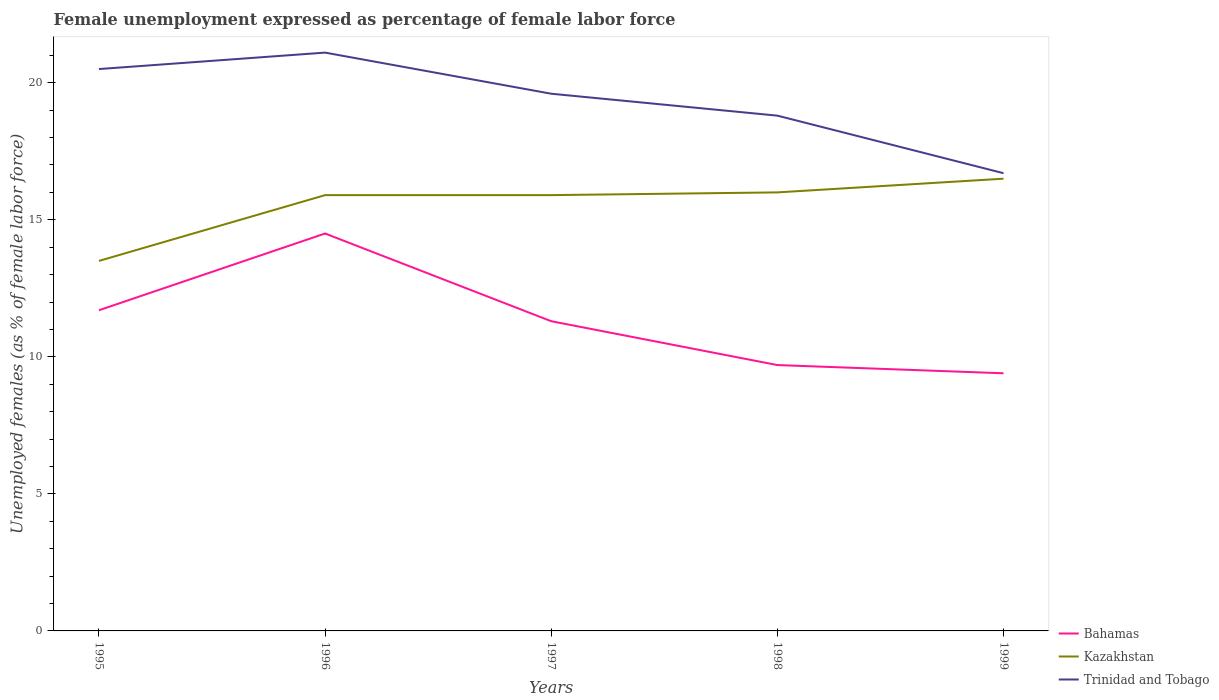How many different coloured lines are there?
Offer a terse response. 3. Is the number of lines equal to the number of legend labels?
Your answer should be compact. Yes. Across all years, what is the maximum unemployment in females in in Trinidad and Tobago?
Your response must be concise. 16.7. In which year was the unemployment in females in in Kazakhstan maximum?
Your answer should be very brief. 1995. What is the total unemployment in females in in Trinidad and Tobago in the graph?
Your response must be concise. 2.9. What is the difference between the highest and the second highest unemployment in females in in Trinidad and Tobago?
Your response must be concise. 4.4. What is the difference between the highest and the lowest unemployment in females in in Kazakhstan?
Provide a short and direct response. 4. Is the unemployment in females in in Bahamas strictly greater than the unemployment in females in in Kazakhstan over the years?
Offer a terse response. Yes. How many lines are there?
Your answer should be very brief. 3. How many years are there in the graph?
Your answer should be compact. 5. Does the graph contain any zero values?
Your answer should be very brief. No. How many legend labels are there?
Provide a succinct answer. 3. How are the legend labels stacked?
Offer a very short reply. Vertical. What is the title of the graph?
Offer a terse response. Female unemployment expressed as percentage of female labor force. What is the label or title of the Y-axis?
Your answer should be very brief. Unemployed females (as % of female labor force). What is the Unemployed females (as % of female labor force) in Bahamas in 1995?
Offer a terse response. 11.7. What is the Unemployed females (as % of female labor force) of Kazakhstan in 1995?
Provide a succinct answer. 13.5. What is the Unemployed females (as % of female labor force) of Trinidad and Tobago in 1995?
Ensure brevity in your answer.  20.5. What is the Unemployed females (as % of female labor force) of Kazakhstan in 1996?
Ensure brevity in your answer.  15.9. What is the Unemployed females (as % of female labor force) in Trinidad and Tobago in 1996?
Your answer should be compact. 21.1. What is the Unemployed females (as % of female labor force) of Bahamas in 1997?
Provide a short and direct response. 11.3. What is the Unemployed females (as % of female labor force) of Kazakhstan in 1997?
Keep it short and to the point. 15.9. What is the Unemployed females (as % of female labor force) of Trinidad and Tobago in 1997?
Provide a short and direct response. 19.6. What is the Unemployed females (as % of female labor force) of Bahamas in 1998?
Ensure brevity in your answer.  9.7. What is the Unemployed females (as % of female labor force) of Trinidad and Tobago in 1998?
Make the answer very short. 18.8. What is the Unemployed females (as % of female labor force) in Bahamas in 1999?
Offer a terse response. 9.4. What is the Unemployed females (as % of female labor force) of Kazakhstan in 1999?
Give a very brief answer. 16.5. What is the Unemployed females (as % of female labor force) in Trinidad and Tobago in 1999?
Give a very brief answer. 16.7. Across all years, what is the maximum Unemployed females (as % of female labor force) in Kazakhstan?
Make the answer very short. 16.5. Across all years, what is the maximum Unemployed females (as % of female labor force) in Trinidad and Tobago?
Your answer should be compact. 21.1. Across all years, what is the minimum Unemployed females (as % of female labor force) in Bahamas?
Give a very brief answer. 9.4. Across all years, what is the minimum Unemployed females (as % of female labor force) in Kazakhstan?
Offer a very short reply. 13.5. Across all years, what is the minimum Unemployed females (as % of female labor force) of Trinidad and Tobago?
Keep it short and to the point. 16.7. What is the total Unemployed females (as % of female labor force) in Bahamas in the graph?
Keep it short and to the point. 56.6. What is the total Unemployed females (as % of female labor force) of Kazakhstan in the graph?
Keep it short and to the point. 77.8. What is the total Unemployed females (as % of female labor force) in Trinidad and Tobago in the graph?
Make the answer very short. 96.7. What is the difference between the Unemployed females (as % of female labor force) in Kazakhstan in 1995 and that in 1996?
Ensure brevity in your answer.  -2.4. What is the difference between the Unemployed females (as % of female labor force) of Kazakhstan in 1995 and that in 1997?
Ensure brevity in your answer.  -2.4. What is the difference between the Unemployed females (as % of female labor force) of Trinidad and Tobago in 1995 and that in 1997?
Give a very brief answer. 0.9. What is the difference between the Unemployed females (as % of female labor force) of Kazakhstan in 1995 and that in 1999?
Your answer should be very brief. -3. What is the difference between the Unemployed females (as % of female labor force) of Trinidad and Tobago in 1995 and that in 1999?
Offer a very short reply. 3.8. What is the difference between the Unemployed females (as % of female labor force) in Bahamas in 1996 and that in 1997?
Provide a succinct answer. 3.2. What is the difference between the Unemployed females (as % of female labor force) in Kazakhstan in 1996 and that in 1997?
Your response must be concise. 0. What is the difference between the Unemployed females (as % of female labor force) of Trinidad and Tobago in 1996 and that in 1997?
Make the answer very short. 1.5. What is the difference between the Unemployed females (as % of female labor force) of Bahamas in 1996 and that in 1999?
Make the answer very short. 5.1. What is the difference between the Unemployed females (as % of female labor force) of Trinidad and Tobago in 1996 and that in 1999?
Give a very brief answer. 4.4. What is the difference between the Unemployed females (as % of female labor force) of Kazakhstan in 1997 and that in 1998?
Offer a very short reply. -0.1. What is the difference between the Unemployed females (as % of female labor force) of Trinidad and Tobago in 1997 and that in 1998?
Offer a very short reply. 0.8. What is the difference between the Unemployed females (as % of female labor force) of Bahamas in 1997 and that in 1999?
Provide a succinct answer. 1.9. What is the difference between the Unemployed females (as % of female labor force) of Bahamas in 1998 and that in 1999?
Give a very brief answer. 0.3. What is the difference between the Unemployed females (as % of female labor force) of Trinidad and Tobago in 1998 and that in 1999?
Make the answer very short. 2.1. What is the difference between the Unemployed females (as % of female labor force) of Bahamas in 1995 and the Unemployed females (as % of female labor force) of Kazakhstan in 1997?
Keep it short and to the point. -4.2. What is the difference between the Unemployed females (as % of female labor force) in Bahamas in 1995 and the Unemployed females (as % of female labor force) in Trinidad and Tobago in 1997?
Ensure brevity in your answer.  -7.9. What is the difference between the Unemployed females (as % of female labor force) of Kazakhstan in 1995 and the Unemployed females (as % of female labor force) of Trinidad and Tobago in 1997?
Your answer should be very brief. -6.1. What is the difference between the Unemployed females (as % of female labor force) in Bahamas in 1995 and the Unemployed females (as % of female labor force) in Kazakhstan in 1998?
Make the answer very short. -4.3. What is the difference between the Unemployed females (as % of female labor force) in Kazakhstan in 1995 and the Unemployed females (as % of female labor force) in Trinidad and Tobago in 1998?
Ensure brevity in your answer.  -5.3. What is the difference between the Unemployed females (as % of female labor force) of Bahamas in 1995 and the Unemployed females (as % of female labor force) of Kazakhstan in 1999?
Provide a succinct answer. -4.8. What is the difference between the Unemployed females (as % of female labor force) in Bahamas in 1996 and the Unemployed females (as % of female labor force) in Trinidad and Tobago in 1997?
Your response must be concise. -5.1. What is the difference between the Unemployed females (as % of female labor force) of Bahamas in 1996 and the Unemployed females (as % of female labor force) of Kazakhstan in 1999?
Give a very brief answer. -2. What is the difference between the Unemployed females (as % of female labor force) in Kazakhstan in 1997 and the Unemployed females (as % of female labor force) in Trinidad and Tobago in 1998?
Your response must be concise. -2.9. What is the difference between the Unemployed females (as % of female labor force) of Bahamas in 1997 and the Unemployed females (as % of female labor force) of Kazakhstan in 1999?
Provide a succinct answer. -5.2. What is the difference between the Unemployed females (as % of female labor force) of Bahamas in 1997 and the Unemployed females (as % of female labor force) of Trinidad and Tobago in 1999?
Offer a terse response. -5.4. What is the difference between the Unemployed females (as % of female labor force) in Kazakhstan in 1998 and the Unemployed females (as % of female labor force) in Trinidad and Tobago in 1999?
Keep it short and to the point. -0.7. What is the average Unemployed females (as % of female labor force) of Bahamas per year?
Your answer should be very brief. 11.32. What is the average Unemployed females (as % of female labor force) in Kazakhstan per year?
Make the answer very short. 15.56. What is the average Unemployed females (as % of female labor force) of Trinidad and Tobago per year?
Offer a terse response. 19.34. In the year 1995, what is the difference between the Unemployed females (as % of female labor force) of Bahamas and Unemployed females (as % of female labor force) of Trinidad and Tobago?
Your response must be concise. -8.8. In the year 1996, what is the difference between the Unemployed females (as % of female labor force) in Bahamas and Unemployed females (as % of female labor force) in Kazakhstan?
Offer a terse response. -1.4. In the year 1996, what is the difference between the Unemployed females (as % of female labor force) of Bahamas and Unemployed females (as % of female labor force) of Trinidad and Tobago?
Ensure brevity in your answer.  -6.6. In the year 1996, what is the difference between the Unemployed females (as % of female labor force) in Kazakhstan and Unemployed females (as % of female labor force) in Trinidad and Tobago?
Give a very brief answer. -5.2. In the year 1997, what is the difference between the Unemployed females (as % of female labor force) of Bahamas and Unemployed females (as % of female labor force) of Trinidad and Tobago?
Provide a short and direct response. -8.3. In the year 1997, what is the difference between the Unemployed females (as % of female labor force) of Kazakhstan and Unemployed females (as % of female labor force) of Trinidad and Tobago?
Keep it short and to the point. -3.7. In the year 1998, what is the difference between the Unemployed females (as % of female labor force) in Kazakhstan and Unemployed females (as % of female labor force) in Trinidad and Tobago?
Ensure brevity in your answer.  -2.8. What is the ratio of the Unemployed females (as % of female labor force) of Bahamas in 1995 to that in 1996?
Offer a very short reply. 0.81. What is the ratio of the Unemployed females (as % of female labor force) in Kazakhstan in 1995 to that in 1996?
Your answer should be compact. 0.85. What is the ratio of the Unemployed females (as % of female labor force) in Trinidad and Tobago in 1995 to that in 1996?
Make the answer very short. 0.97. What is the ratio of the Unemployed females (as % of female labor force) in Bahamas in 1995 to that in 1997?
Ensure brevity in your answer.  1.04. What is the ratio of the Unemployed females (as % of female labor force) of Kazakhstan in 1995 to that in 1997?
Offer a very short reply. 0.85. What is the ratio of the Unemployed females (as % of female labor force) of Trinidad and Tobago in 1995 to that in 1997?
Provide a succinct answer. 1.05. What is the ratio of the Unemployed females (as % of female labor force) of Bahamas in 1995 to that in 1998?
Ensure brevity in your answer.  1.21. What is the ratio of the Unemployed females (as % of female labor force) in Kazakhstan in 1995 to that in 1998?
Your answer should be compact. 0.84. What is the ratio of the Unemployed females (as % of female labor force) of Trinidad and Tobago in 1995 to that in 1998?
Your answer should be very brief. 1.09. What is the ratio of the Unemployed females (as % of female labor force) in Bahamas in 1995 to that in 1999?
Your answer should be compact. 1.24. What is the ratio of the Unemployed females (as % of female labor force) of Kazakhstan in 1995 to that in 1999?
Provide a short and direct response. 0.82. What is the ratio of the Unemployed females (as % of female labor force) in Trinidad and Tobago in 1995 to that in 1999?
Provide a short and direct response. 1.23. What is the ratio of the Unemployed females (as % of female labor force) of Bahamas in 1996 to that in 1997?
Provide a short and direct response. 1.28. What is the ratio of the Unemployed females (as % of female labor force) of Trinidad and Tobago in 1996 to that in 1997?
Ensure brevity in your answer.  1.08. What is the ratio of the Unemployed females (as % of female labor force) in Bahamas in 1996 to that in 1998?
Keep it short and to the point. 1.49. What is the ratio of the Unemployed females (as % of female labor force) of Kazakhstan in 1996 to that in 1998?
Keep it short and to the point. 0.99. What is the ratio of the Unemployed females (as % of female labor force) in Trinidad and Tobago in 1996 to that in 1998?
Provide a succinct answer. 1.12. What is the ratio of the Unemployed females (as % of female labor force) of Bahamas in 1996 to that in 1999?
Ensure brevity in your answer.  1.54. What is the ratio of the Unemployed females (as % of female labor force) of Kazakhstan in 1996 to that in 1999?
Offer a very short reply. 0.96. What is the ratio of the Unemployed females (as % of female labor force) of Trinidad and Tobago in 1996 to that in 1999?
Provide a succinct answer. 1.26. What is the ratio of the Unemployed females (as % of female labor force) in Bahamas in 1997 to that in 1998?
Give a very brief answer. 1.16. What is the ratio of the Unemployed females (as % of female labor force) in Trinidad and Tobago in 1997 to that in 1998?
Offer a terse response. 1.04. What is the ratio of the Unemployed females (as % of female labor force) in Bahamas in 1997 to that in 1999?
Make the answer very short. 1.2. What is the ratio of the Unemployed females (as % of female labor force) of Kazakhstan in 1997 to that in 1999?
Provide a succinct answer. 0.96. What is the ratio of the Unemployed females (as % of female labor force) of Trinidad and Tobago in 1997 to that in 1999?
Give a very brief answer. 1.17. What is the ratio of the Unemployed females (as % of female labor force) of Bahamas in 1998 to that in 1999?
Give a very brief answer. 1.03. What is the ratio of the Unemployed females (as % of female labor force) in Kazakhstan in 1998 to that in 1999?
Your answer should be compact. 0.97. What is the ratio of the Unemployed females (as % of female labor force) in Trinidad and Tobago in 1998 to that in 1999?
Ensure brevity in your answer.  1.13. What is the difference between the highest and the second highest Unemployed females (as % of female labor force) of Bahamas?
Provide a succinct answer. 2.8. What is the difference between the highest and the second highest Unemployed females (as % of female labor force) of Kazakhstan?
Keep it short and to the point. 0.5. What is the difference between the highest and the second highest Unemployed females (as % of female labor force) in Trinidad and Tobago?
Make the answer very short. 0.6. What is the difference between the highest and the lowest Unemployed females (as % of female labor force) of Kazakhstan?
Offer a terse response. 3. What is the difference between the highest and the lowest Unemployed females (as % of female labor force) of Trinidad and Tobago?
Your answer should be compact. 4.4. 